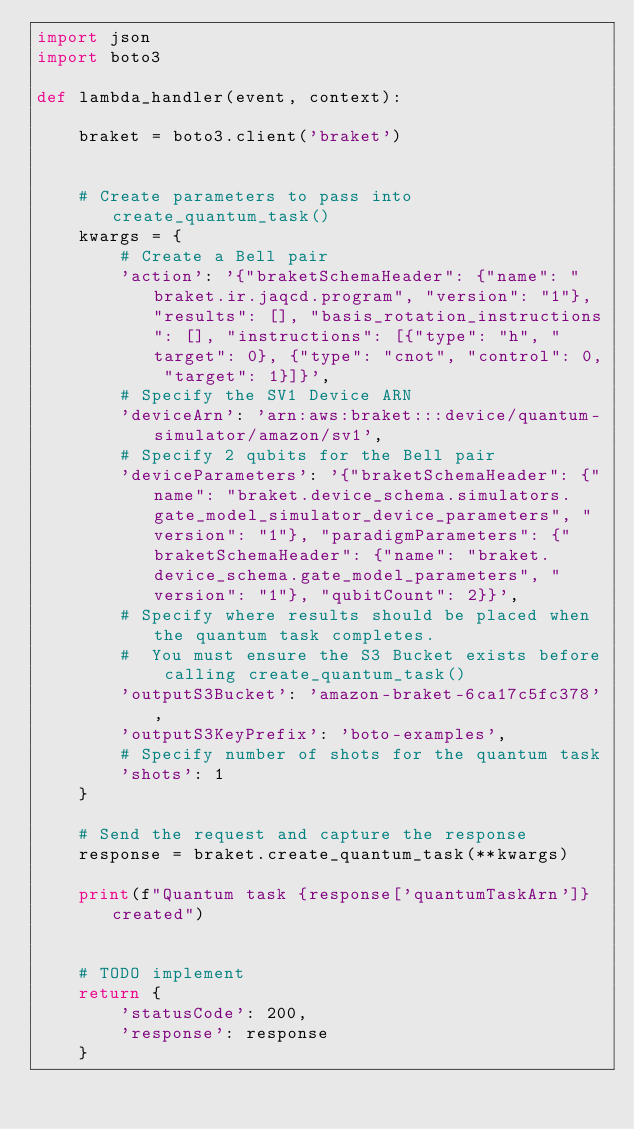<code> <loc_0><loc_0><loc_500><loc_500><_Python_>import json
import boto3

def lambda_handler(event, context):

    braket = boto3.client('braket')


    # Create parameters to pass into create_quantum_task()
    kwargs = {
        # Create a Bell pair
        'action': '{"braketSchemaHeader": {"name": "braket.ir.jaqcd.program", "version": "1"}, "results": [], "basis_rotation_instructions": [], "instructions": [{"type": "h", "target": 0}, {"type": "cnot", "control": 0, "target": 1}]}',
        # Specify the SV1 Device ARN
        'deviceArn': 'arn:aws:braket:::device/quantum-simulator/amazon/sv1',
        # Specify 2 qubits for the Bell pair
        'deviceParameters': '{"braketSchemaHeader": {"name": "braket.device_schema.simulators.gate_model_simulator_device_parameters", "version": "1"}, "paradigmParameters": {"braketSchemaHeader": {"name": "braket.device_schema.gate_model_parameters", "version": "1"}, "qubitCount": 2}}',
        # Specify where results should be placed when the quantum task completes.
        #  You must ensure the S3 Bucket exists before calling create_quantum_task()
        'outputS3Bucket': 'amazon-braket-6ca17c5fc378',
        'outputS3KeyPrefix': 'boto-examples',
        # Specify number of shots for the quantum task
        'shots': 1
    }

    # Send the request and capture the response
    response = braket.create_quantum_task(**kwargs)

    print(f"Quantum task {response['quantumTaskArn']} created")


    # TODO implement
    return {
        'statusCode': 200,
        'response': response
    }
</code> 